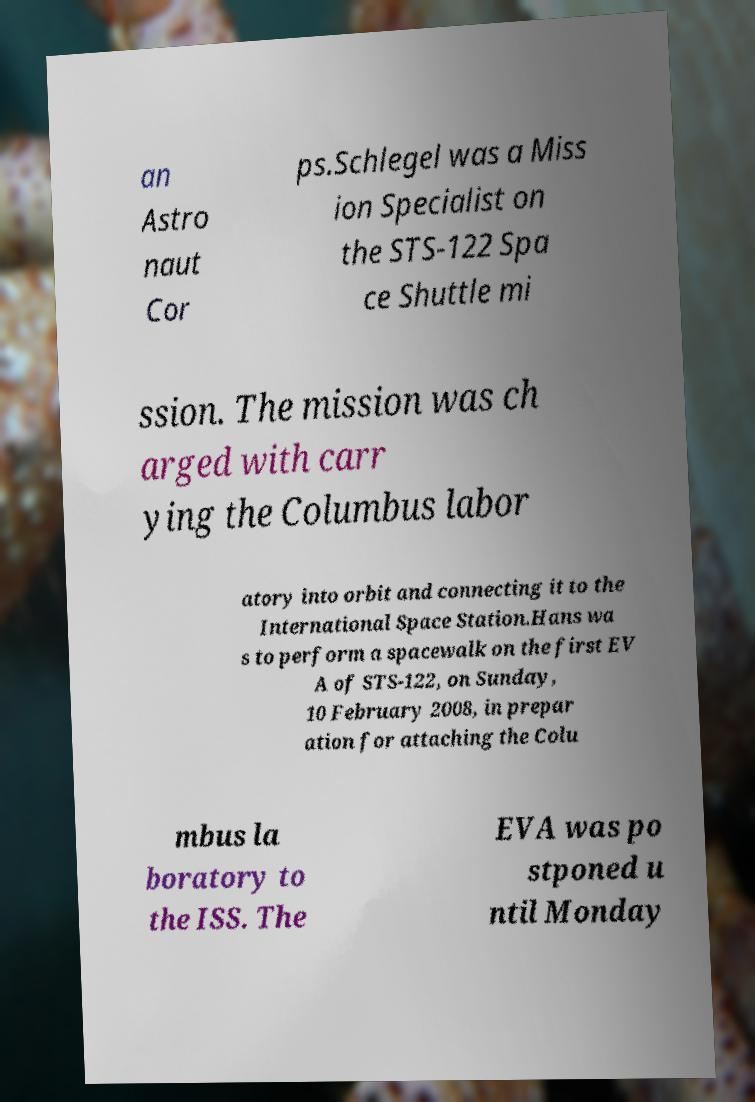Please read and relay the text visible in this image. What does it say? an Astro naut Cor ps.Schlegel was a Miss ion Specialist on the STS-122 Spa ce Shuttle mi ssion. The mission was ch arged with carr ying the Columbus labor atory into orbit and connecting it to the International Space Station.Hans wa s to perform a spacewalk on the first EV A of STS-122, on Sunday, 10 February 2008, in prepar ation for attaching the Colu mbus la boratory to the ISS. The EVA was po stponed u ntil Monday 